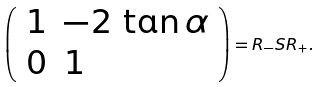Convert formula to latex. <formula><loc_0><loc_0><loc_500><loc_500>\left ( \begin{array} { l l } { 1 } & { - 2 \, \tan \alpha } \\ { 0 } & { 1 } \end{array} \right ) = R _ { - } S R _ { + } .</formula> 